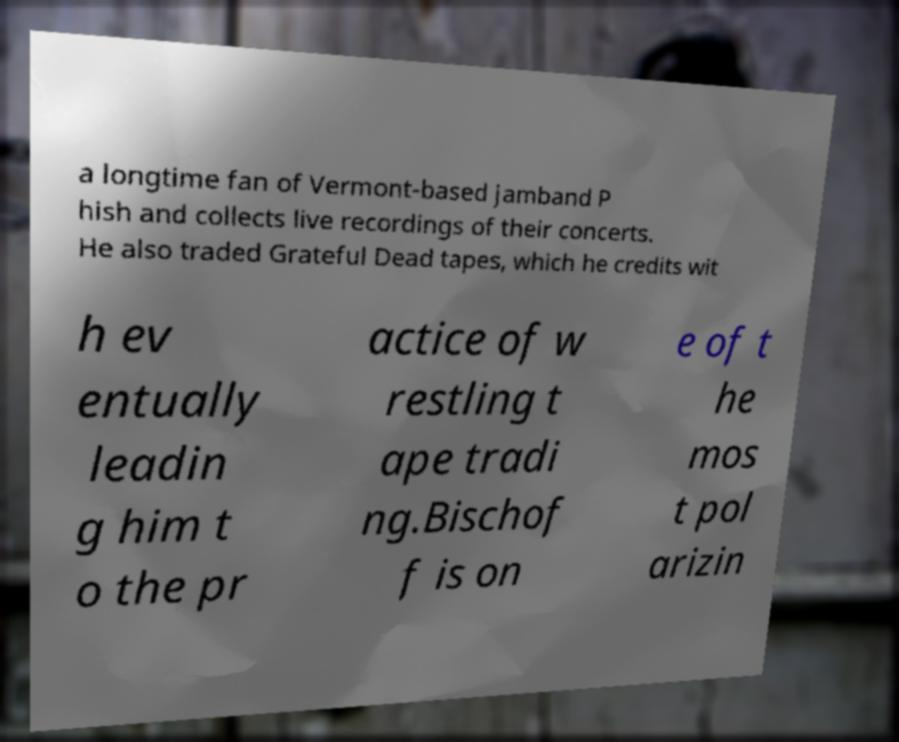Please read and relay the text visible in this image. What does it say? a longtime fan of Vermont-based jamband P hish and collects live recordings of their concerts. He also traded Grateful Dead tapes, which he credits wit h ev entually leadin g him t o the pr actice of w restling t ape tradi ng.Bischof f is on e of t he mos t pol arizin 